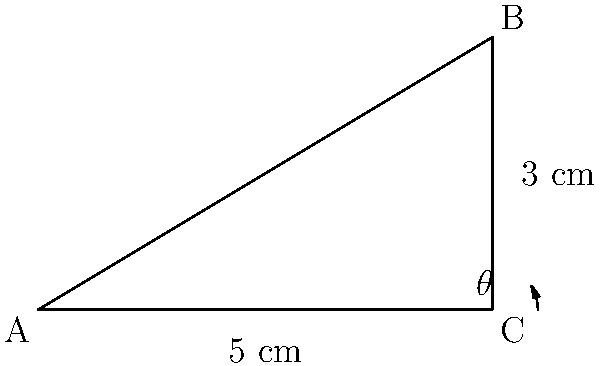In a cell culture experiment, a slanted surface is used to optimize cell growth. The surface has a base length of 5 cm and a height of 3 cm, as shown in the diagram. What is the angle of inclination ($\theta$) of the culture surface, rounded to the nearest degree? To find the angle of inclination ($\theta$), we can use the inverse tangent (arctangent) function. Here's how we solve it step-by-step:

1. Identify the right triangle formed by the culture surface:
   - The base of the triangle is 5 cm
   - The height of the triangle is 3 cm

2. The angle $\theta$ is formed between the base and the hypotenuse (slanted surface)

3. In a right triangle, $\tan(\theta) = \frac{\text{opposite}}{\text{adjacent}}$

4. In this case:
   $\tan(\theta) = \frac{\text{height}}{\text{base}} = \frac{3}{5}$

5. To find $\theta$, we need to use the inverse tangent function:
   $\theta = \tan^{-1}(\frac{3}{5})$

6. Using a calculator or computer:
   $\theta = \tan^{-1}(0.6) \approx 30.9638^\circ$

7. Rounding to the nearest degree:
   $\theta \approx 31^\circ$

Therefore, the angle of inclination of the culture surface is approximately 31°.
Answer: $31^\circ$ 